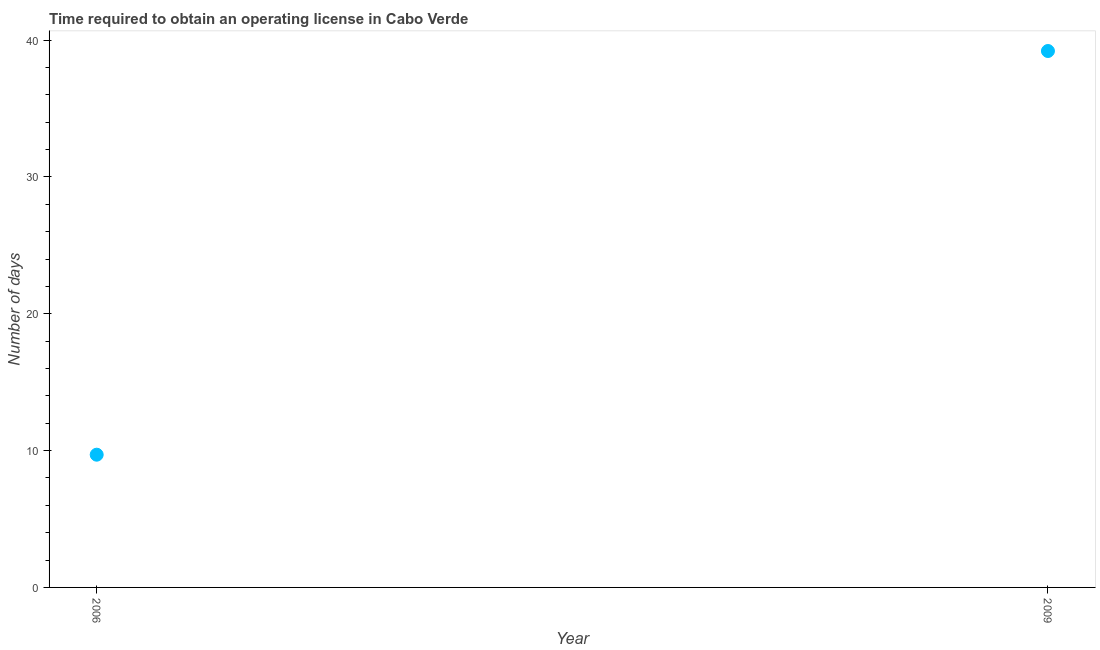What is the number of days to obtain operating license in 2006?
Your answer should be compact. 9.7. Across all years, what is the maximum number of days to obtain operating license?
Provide a short and direct response. 39.2. In which year was the number of days to obtain operating license maximum?
Keep it short and to the point. 2009. What is the sum of the number of days to obtain operating license?
Your response must be concise. 48.9. What is the difference between the number of days to obtain operating license in 2006 and 2009?
Your answer should be very brief. -29.5. What is the average number of days to obtain operating license per year?
Ensure brevity in your answer.  24.45. What is the median number of days to obtain operating license?
Make the answer very short. 24.45. Do a majority of the years between 2009 and 2006 (inclusive) have number of days to obtain operating license greater than 32 days?
Your answer should be very brief. No. What is the ratio of the number of days to obtain operating license in 2006 to that in 2009?
Keep it short and to the point. 0.25. In how many years, is the number of days to obtain operating license greater than the average number of days to obtain operating license taken over all years?
Your answer should be very brief. 1. How many years are there in the graph?
Your answer should be very brief. 2. What is the difference between two consecutive major ticks on the Y-axis?
Keep it short and to the point. 10. Are the values on the major ticks of Y-axis written in scientific E-notation?
Your answer should be compact. No. What is the title of the graph?
Make the answer very short. Time required to obtain an operating license in Cabo Verde. What is the label or title of the X-axis?
Your response must be concise. Year. What is the label or title of the Y-axis?
Your answer should be very brief. Number of days. What is the Number of days in 2009?
Keep it short and to the point. 39.2. What is the difference between the Number of days in 2006 and 2009?
Offer a terse response. -29.5. What is the ratio of the Number of days in 2006 to that in 2009?
Keep it short and to the point. 0.25. 